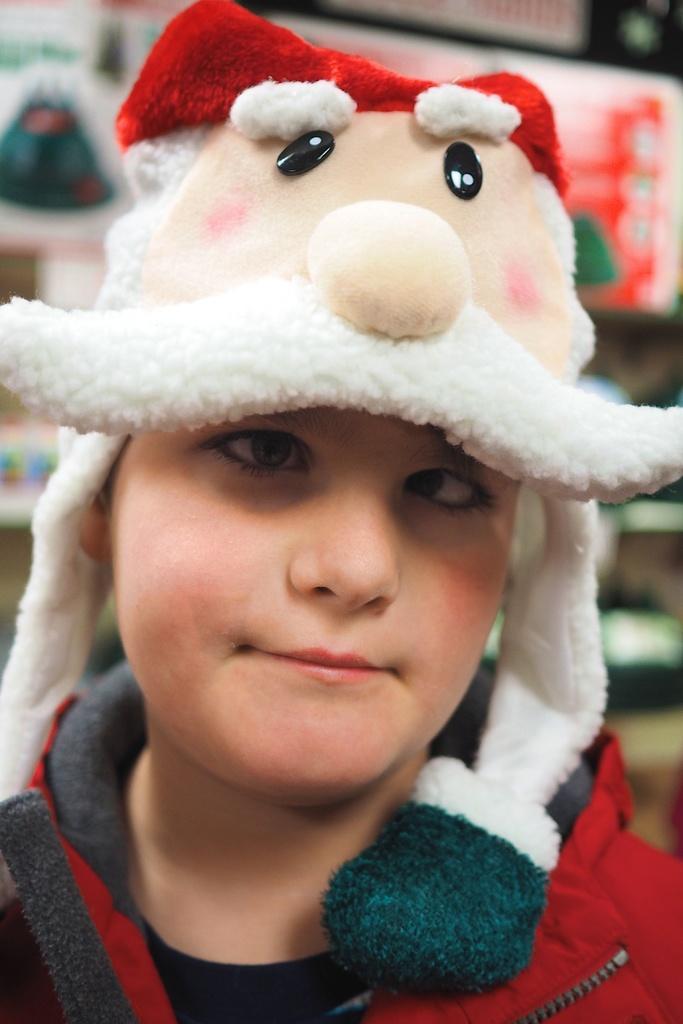Could you give a brief overview of what you see in this image? In this image I can see a person is wearing a red color jacket and a cap on the head and looking at the picture. In the background I can see some objects in the rack. 